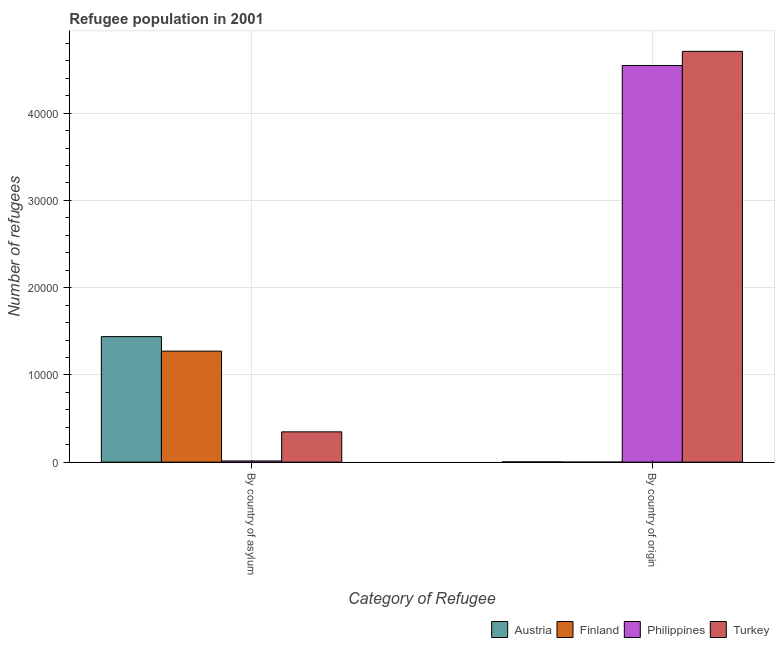Are the number of bars per tick equal to the number of legend labels?
Make the answer very short. Yes. Are the number of bars on each tick of the X-axis equal?
Your answer should be compact. Yes. How many bars are there on the 2nd tick from the left?
Provide a short and direct response. 4. What is the label of the 1st group of bars from the left?
Your answer should be very brief. By country of asylum. What is the number of refugees by country of asylum in Philippines?
Your answer should be very brief. 136. Across all countries, what is the maximum number of refugees by country of origin?
Keep it short and to the point. 4.71e+04. Across all countries, what is the minimum number of refugees by country of origin?
Your response must be concise. 2. In which country was the number of refugees by country of asylum maximum?
Provide a short and direct response. Austria. What is the total number of refugees by country of origin in the graph?
Ensure brevity in your answer.  9.26e+04. What is the difference between the number of refugees by country of asylum in Finland and that in Turkey?
Ensure brevity in your answer.  9256. What is the difference between the number of refugees by country of origin in Austria and the number of refugees by country of asylum in Turkey?
Keep it short and to the point. -3443. What is the average number of refugees by country of origin per country?
Provide a succinct answer. 2.31e+04. What is the difference between the number of refugees by country of origin and number of refugees by country of asylum in Turkey?
Your response must be concise. 4.36e+04. What is the ratio of the number of refugees by country of origin in Turkey to that in Philippines?
Ensure brevity in your answer.  1.04. What is the difference between two consecutive major ticks on the Y-axis?
Make the answer very short. 10000. Are the values on the major ticks of Y-axis written in scientific E-notation?
Keep it short and to the point. No. How many legend labels are there?
Ensure brevity in your answer.  4. How are the legend labels stacked?
Give a very brief answer. Horizontal. What is the title of the graph?
Offer a terse response. Refugee population in 2001. Does "Bhutan" appear as one of the legend labels in the graph?
Keep it short and to the point. No. What is the label or title of the X-axis?
Offer a very short reply. Category of Refugee. What is the label or title of the Y-axis?
Your answer should be compact. Number of refugees. What is the Number of refugees in Austria in By country of asylum?
Your answer should be compact. 1.44e+04. What is the Number of refugees of Finland in By country of asylum?
Make the answer very short. 1.27e+04. What is the Number of refugees of Philippines in By country of asylum?
Offer a very short reply. 136. What is the Number of refugees of Turkey in By country of asylum?
Provide a succinct answer. 3472. What is the Number of refugees in Philippines in By country of origin?
Offer a very short reply. 4.55e+04. What is the Number of refugees in Turkey in By country of origin?
Your answer should be compact. 4.71e+04. Across all Category of Refugee, what is the maximum Number of refugees in Austria?
Provide a succinct answer. 1.44e+04. Across all Category of Refugee, what is the maximum Number of refugees of Finland?
Provide a succinct answer. 1.27e+04. Across all Category of Refugee, what is the maximum Number of refugees of Philippines?
Provide a succinct answer. 4.55e+04. Across all Category of Refugee, what is the maximum Number of refugees of Turkey?
Your answer should be compact. 4.71e+04. Across all Category of Refugee, what is the minimum Number of refugees in Philippines?
Ensure brevity in your answer.  136. Across all Category of Refugee, what is the minimum Number of refugees in Turkey?
Your response must be concise. 3472. What is the total Number of refugees of Austria in the graph?
Offer a very short reply. 1.44e+04. What is the total Number of refugees in Finland in the graph?
Keep it short and to the point. 1.27e+04. What is the total Number of refugees in Philippines in the graph?
Offer a very short reply. 4.56e+04. What is the total Number of refugees of Turkey in the graph?
Keep it short and to the point. 5.06e+04. What is the difference between the Number of refugees in Austria in By country of asylum and that in By country of origin?
Provide a succinct answer. 1.44e+04. What is the difference between the Number of refugees in Finland in By country of asylum and that in By country of origin?
Offer a very short reply. 1.27e+04. What is the difference between the Number of refugees in Philippines in By country of asylum and that in By country of origin?
Make the answer very short. -4.53e+04. What is the difference between the Number of refugees of Turkey in By country of asylum and that in By country of origin?
Make the answer very short. -4.36e+04. What is the difference between the Number of refugees of Austria in By country of asylum and the Number of refugees of Finland in By country of origin?
Make the answer very short. 1.44e+04. What is the difference between the Number of refugees of Austria in By country of asylum and the Number of refugees of Philippines in By country of origin?
Give a very brief answer. -3.11e+04. What is the difference between the Number of refugees in Austria in By country of asylum and the Number of refugees in Turkey in By country of origin?
Give a very brief answer. -3.27e+04. What is the difference between the Number of refugees of Finland in By country of asylum and the Number of refugees of Philippines in By country of origin?
Your answer should be very brief. -3.27e+04. What is the difference between the Number of refugees of Finland in By country of asylum and the Number of refugees of Turkey in By country of origin?
Give a very brief answer. -3.44e+04. What is the difference between the Number of refugees of Philippines in By country of asylum and the Number of refugees of Turkey in By country of origin?
Make the answer very short. -4.70e+04. What is the average Number of refugees in Austria per Category of Refugee?
Offer a very short reply. 7209.5. What is the average Number of refugees of Finland per Category of Refugee?
Offer a terse response. 6365. What is the average Number of refugees of Philippines per Category of Refugee?
Give a very brief answer. 2.28e+04. What is the average Number of refugees of Turkey per Category of Refugee?
Your answer should be compact. 2.53e+04. What is the difference between the Number of refugees in Austria and Number of refugees in Finland in By country of asylum?
Your response must be concise. 1662. What is the difference between the Number of refugees in Austria and Number of refugees in Philippines in By country of asylum?
Make the answer very short. 1.43e+04. What is the difference between the Number of refugees of Austria and Number of refugees of Turkey in By country of asylum?
Provide a succinct answer. 1.09e+04. What is the difference between the Number of refugees of Finland and Number of refugees of Philippines in By country of asylum?
Give a very brief answer. 1.26e+04. What is the difference between the Number of refugees of Finland and Number of refugees of Turkey in By country of asylum?
Offer a very short reply. 9256. What is the difference between the Number of refugees in Philippines and Number of refugees in Turkey in By country of asylum?
Offer a very short reply. -3336. What is the difference between the Number of refugees of Austria and Number of refugees of Philippines in By country of origin?
Offer a very short reply. -4.54e+04. What is the difference between the Number of refugees in Austria and Number of refugees in Turkey in By country of origin?
Offer a terse response. -4.71e+04. What is the difference between the Number of refugees of Finland and Number of refugees of Philippines in By country of origin?
Your response must be concise. -4.55e+04. What is the difference between the Number of refugees of Finland and Number of refugees of Turkey in By country of origin?
Keep it short and to the point. -4.71e+04. What is the difference between the Number of refugees of Philippines and Number of refugees of Turkey in By country of origin?
Keep it short and to the point. -1623. What is the ratio of the Number of refugees of Austria in By country of asylum to that in By country of origin?
Provide a short and direct response. 496.21. What is the ratio of the Number of refugees of Finland in By country of asylum to that in By country of origin?
Your answer should be very brief. 6364. What is the ratio of the Number of refugees of Philippines in By country of asylum to that in By country of origin?
Provide a short and direct response. 0. What is the ratio of the Number of refugees in Turkey in By country of asylum to that in By country of origin?
Provide a succinct answer. 0.07. What is the difference between the highest and the second highest Number of refugees in Austria?
Provide a succinct answer. 1.44e+04. What is the difference between the highest and the second highest Number of refugees of Finland?
Offer a terse response. 1.27e+04. What is the difference between the highest and the second highest Number of refugees in Philippines?
Provide a short and direct response. 4.53e+04. What is the difference between the highest and the second highest Number of refugees in Turkey?
Provide a succinct answer. 4.36e+04. What is the difference between the highest and the lowest Number of refugees in Austria?
Keep it short and to the point. 1.44e+04. What is the difference between the highest and the lowest Number of refugees in Finland?
Your answer should be compact. 1.27e+04. What is the difference between the highest and the lowest Number of refugees in Philippines?
Offer a terse response. 4.53e+04. What is the difference between the highest and the lowest Number of refugees in Turkey?
Offer a very short reply. 4.36e+04. 